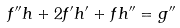Convert formula to latex. <formula><loc_0><loc_0><loc_500><loc_500>f ^ { \prime \prime } h + 2 f ^ { \prime } h ^ { \prime } + f h ^ { \prime \prime } = g ^ { \prime \prime }</formula> 